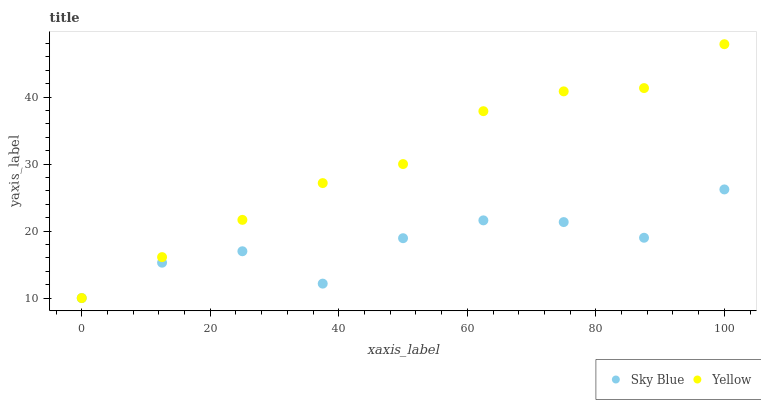Does Sky Blue have the minimum area under the curve?
Answer yes or no. Yes. Does Yellow have the maximum area under the curve?
Answer yes or no. Yes. Does Yellow have the minimum area under the curve?
Answer yes or no. No. Is Yellow the smoothest?
Answer yes or no. Yes. Is Sky Blue the roughest?
Answer yes or no. Yes. Is Yellow the roughest?
Answer yes or no. No. Does Sky Blue have the lowest value?
Answer yes or no. Yes. Does Yellow have the highest value?
Answer yes or no. Yes. Does Sky Blue intersect Yellow?
Answer yes or no. Yes. Is Sky Blue less than Yellow?
Answer yes or no. No. Is Sky Blue greater than Yellow?
Answer yes or no. No. 